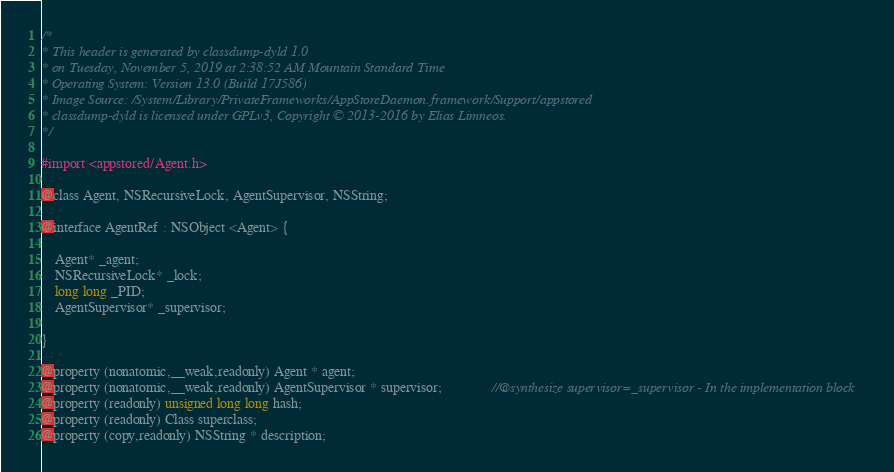Convert code to text. <code><loc_0><loc_0><loc_500><loc_500><_C_>/*
* This header is generated by classdump-dyld 1.0
* on Tuesday, November 5, 2019 at 2:38:52 AM Mountain Standard Time
* Operating System: Version 13.0 (Build 17J586)
* Image Source: /System/Library/PrivateFrameworks/AppStoreDaemon.framework/Support/appstored
* classdump-dyld is licensed under GPLv3, Copyright © 2013-2016 by Elias Limneos.
*/

#import <appstored/Agent.h>

@class Agent, NSRecursiveLock, AgentSupervisor, NSString;

@interface AgentRef : NSObject <Agent> {

	Agent* _agent;
	NSRecursiveLock* _lock;
	long long _PID;
	AgentSupervisor* _supervisor;

}

@property (nonatomic,__weak,readonly) Agent * agent; 
@property (nonatomic,__weak,readonly) AgentSupervisor * supervisor;              //@synthesize supervisor=_supervisor - In the implementation block
@property (readonly) unsigned long long hash; 
@property (readonly) Class superclass; 
@property (copy,readonly) NSString * description; </code> 